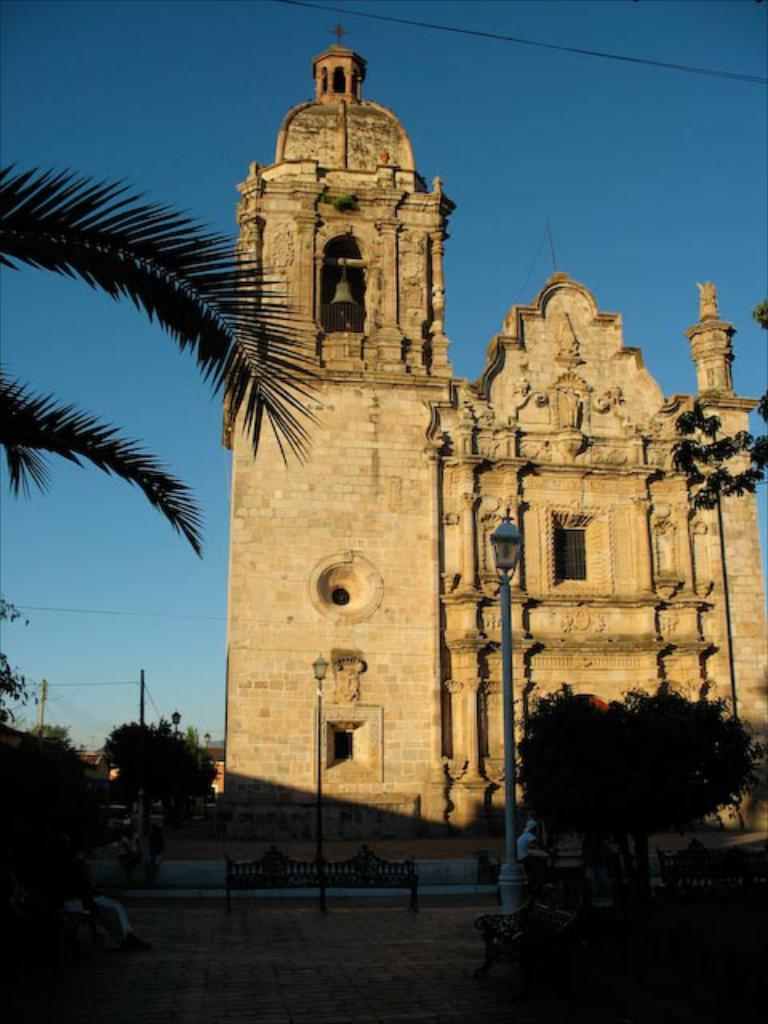What is located in the center of the image? There are persons in the center of the image. What objects are present but not being used in the image? There are empty benches in the image. What type of vertical structures can be seen in the image? There are poles in the image. What type of natural elements are present in the image? There are trees in the image. What type of man-made structures can be seen in the background of the image? There are buildings in the background of the image. What type of vertical structures can be seen in the background of the image? There are poles in the background of the image. Can you tell me how many kites are being flown by the grandmother in the image? There is no grandmother or kite present in the image. Is there a sidewalk visible in the image? The image does not show a sidewalk; it only shows persons, empty benches, poles, trees, buildings, and poles in the background. 